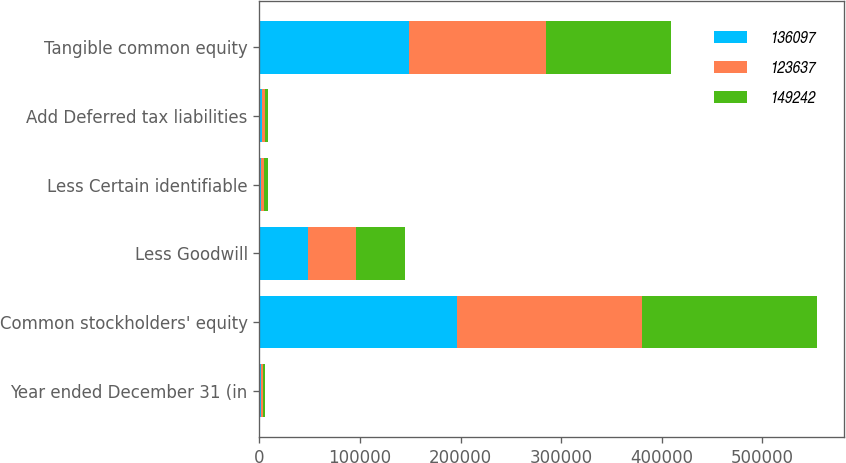Convert chart. <chart><loc_0><loc_0><loc_500><loc_500><stacked_bar_chart><ecel><fcel>Year ended December 31 (in<fcel>Common stockholders' equity<fcel>Less Goodwill<fcel>Less Certain identifiable<fcel>Add Deferred tax liabilities<fcel>Tangible common equity<nl><fcel>136097<fcel>2013<fcel>196409<fcel>48102<fcel>1950<fcel>2885<fcel>149242<nl><fcel>123637<fcel>2012<fcel>184352<fcel>48176<fcel>2833<fcel>2754<fcel>136097<nl><fcel>149242<fcel>2011<fcel>173266<fcel>48632<fcel>3632<fcel>2635<fcel>123637<nl></chart> 